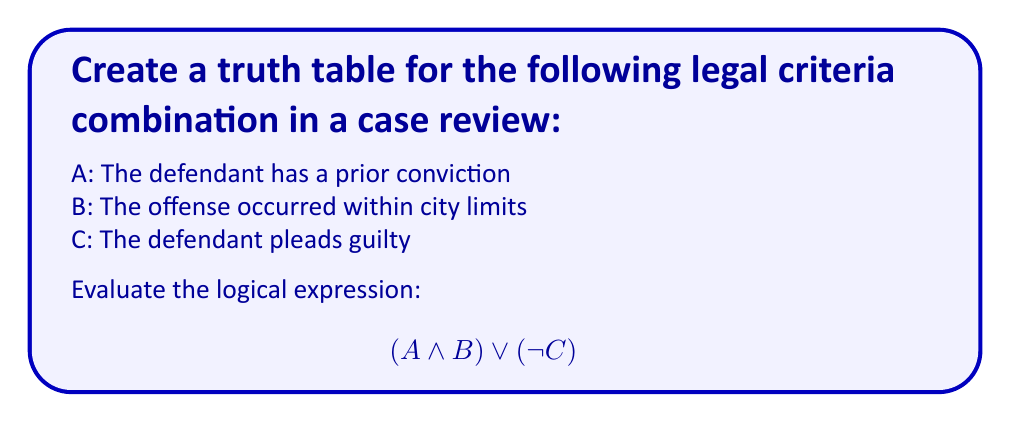Teach me how to tackle this problem. To create a truth table for this logical expression, we need to follow these steps:

1. Identify the variables: A, B, and C
2. List all possible combinations of truth values for these variables
3. Evaluate the sub-expressions: $(A \land B)$ and $(\neg C)$
4. Evaluate the final expression: $(A \land B) \lor (\neg C)$

Step 1: Truth table setup
$$\begin{array}{|c|c|c|c|c|c|}
\hline
A & B & C & (A \land B) & (\neg C) & (A \land B) \lor (\neg C) \\
\hline
\end{array}$$

Step 2: List all possible combinations (8 rows for 3 variables)
$$\begin{array}{|c|c|c|c|c|c|}
\hline
A & B & C & (A \land B) & (\neg C) & (A \land B) \lor (\neg C) \\
\hline
T & T & T &  &  &  \\
T & T & F &  &  &  \\
T & F & T &  &  &  \\
T & F & F &  &  &  \\
F & T & T &  &  &  \\
F & T & F &  &  &  \\
F & F & T &  &  &  \\
F & F & F &  &  &  \\
\hline
\end{array}$$

Step 3: Evaluate $(A \land B)$ and $(\neg C)$
$$\begin{array}{|c|c|c|c|c|c|}
\hline
A & B & C & (A \land B) & (\neg C) & (A \land B) \lor (\neg C) \\
\hline
T & T & T & T & F &  \\
T & T & F & T & T &  \\
T & F & T & F & F &  \\
T & F & F & F & T &  \\
F & T & T & F & F &  \\
F & T & F & F & T &  \\
F & F & T & F & F &  \\
F & F & F & F & T &  \\
\hline
\end{array}$$

Step 4: Evaluate the final expression $(A \land B) \lor (\neg C)$
$$\begin{array}{|c|c|c|c|c|c|}
\hline
A & B & C & (A \land B) & (\neg C) & (A \land B) \lor (\neg C) \\
\hline
T & T & T & T & F & T \\
T & T & F & T & T & T \\
T & F & T & F & F & F \\
T & F & F & F & T & T \\
F & T & T & F & F & F \\
F & T & F & F & T & T \\
F & F & T & F & F & F \\
F & F & F & F & T & T \\
\hline
\end{array}$$

The completed truth table shows all possible outcomes for the given logical expression based on the legal criteria.
Answer: $$\begin{array}{|c|c|c|c|}
\hline
A & B & C & (A \land B) \lor (\neg C) \\
\hline
T & T & T & T \\
T & T & F & T \\
T & F & T & F \\
T & F & F & T \\
F & T & T & F \\
F & T & F & T \\
F & F & T & F \\
F & F & F & T \\
\hline
\end{array}$$ 